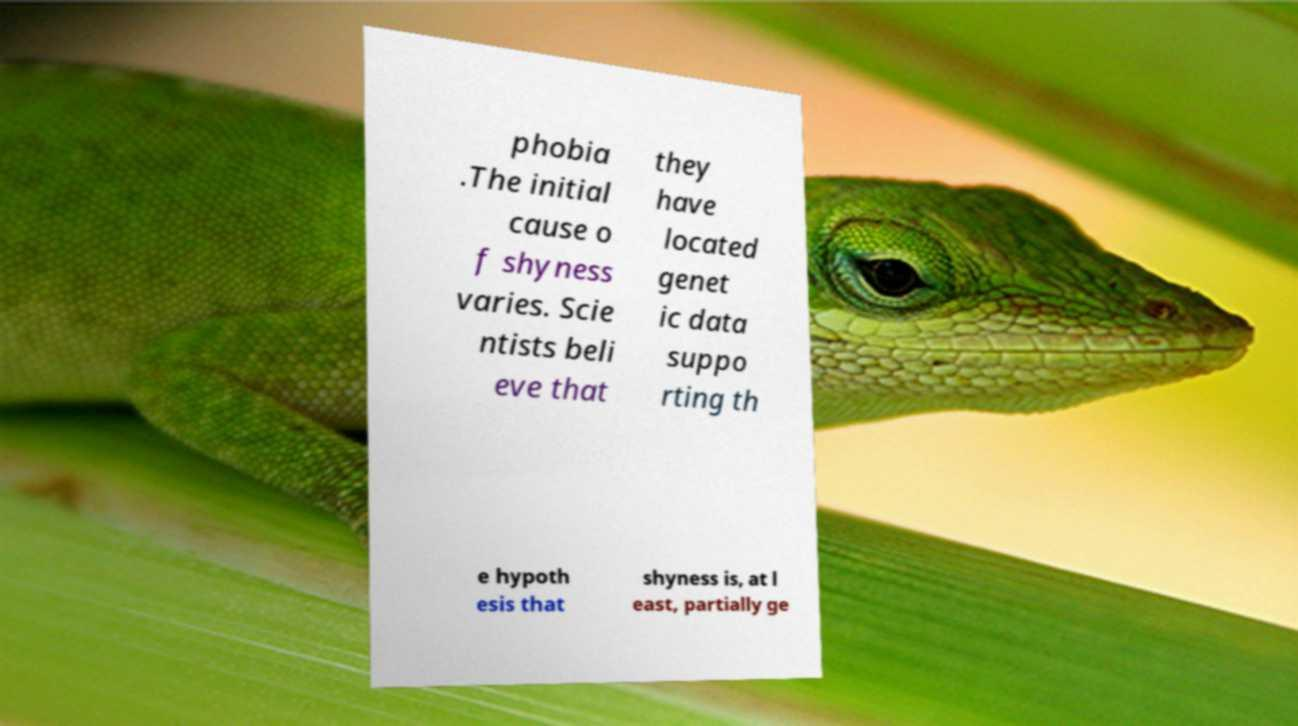Could you assist in decoding the text presented in this image and type it out clearly? phobia .The initial cause o f shyness varies. Scie ntists beli eve that they have located genet ic data suppo rting th e hypoth esis that shyness is, at l east, partially ge 